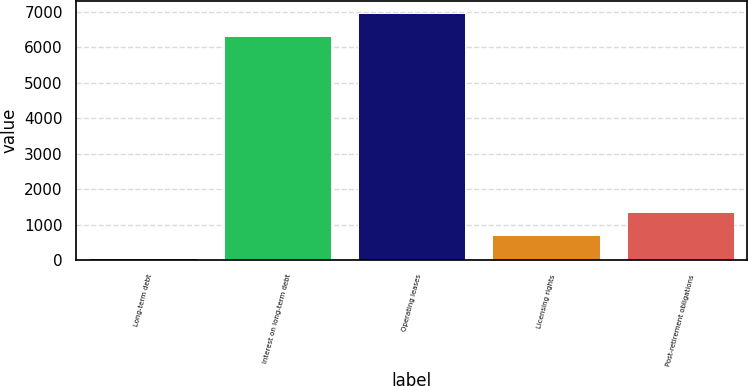Convert chart. <chart><loc_0><loc_0><loc_500><loc_500><bar_chart><fcel>Long-term debt<fcel>Interest on long-term debt<fcel>Operating leases<fcel>Licensing rights<fcel>Post-retirement obligations<nl><fcel>56<fcel>6300<fcel>6947.6<fcel>703.6<fcel>1351.2<nl></chart> 